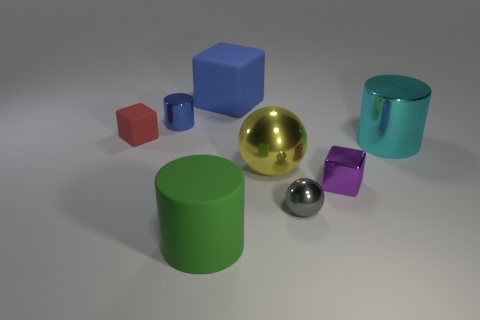Are there any metal cylinders of the same size as the blue cube?
Your answer should be very brief. Yes. What number of cyan things are either shiny cylinders or tiny matte things?
Your response must be concise. 1. What number of rubber cylinders have the same color as the small rubber cube?
Offer a very short reply. 0. How many cubes are matte objects or blue matte things?
Your response must be concise. 2. There is a shiny cylinder to the left of the large green rubber cylinder; what color is it?
Keep it short and to the point. Blue. What shape is the blue object that is the same size as the cyan cylinder?
Offer a very short reply. Cube. There is a purple object; how many things are behind it?
Your response must be concise. 5. How many objects are purple things or brown matte cylinders?
Keep it short and to the point. 1. The tiny thing that is both in front of the tiny cylinder and to the left of the green rubber cylinder has what shape?
Your response must be concise. Cube. What number of big brown cylinders are there?
Your response must be concise. 0. 